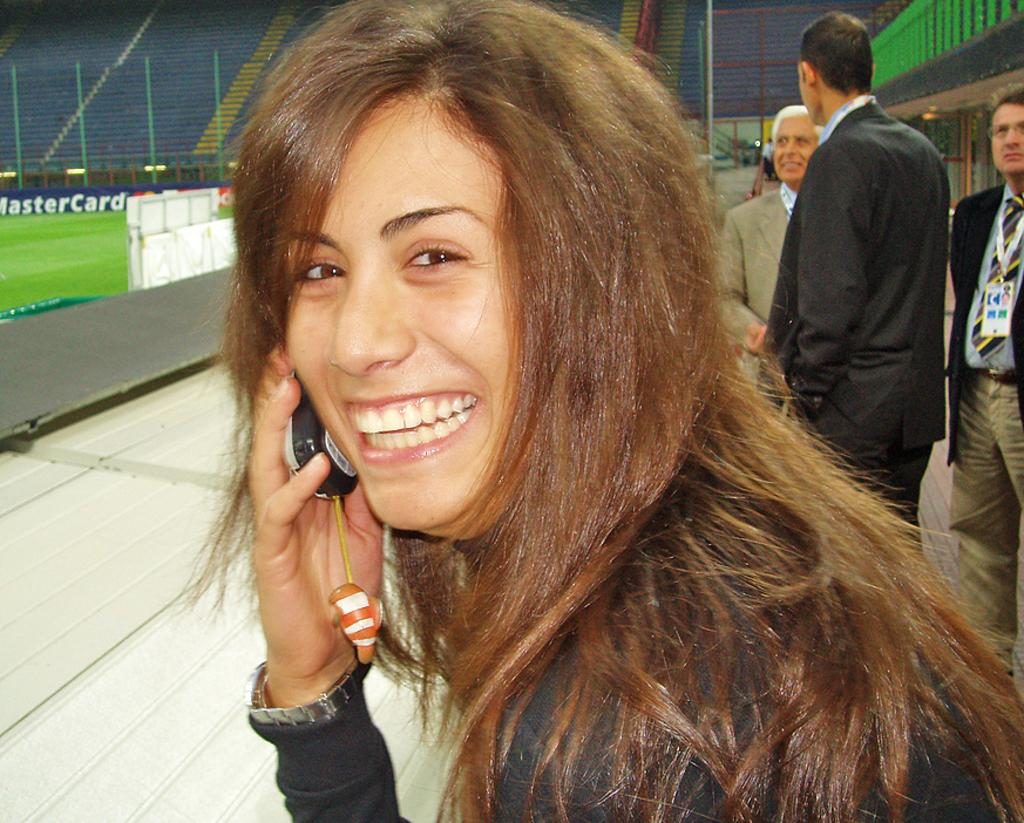Who is the main subject in the image? There is a woman in the center of the image. What is the woman holding in the image? The woman is holding a mobile phone. Can you describe the background of the image? There are persons, the ground, chairs, stairs, and fencing visible in the background of the image. What type of holiday is being celebrated in the image? There is no indication of a holiday being celebrated in the image. How many trees are visible in the image? There are no trees visible in the image. 